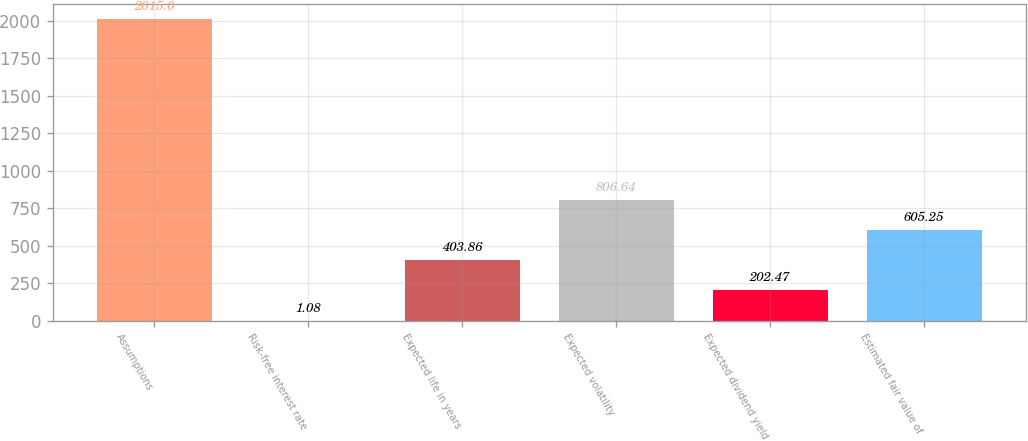<chart> <loc_0><loc_0><loc_500><loc_500><bar_chart><fcel>Assumptions<fcel>Risk-free interest rate<fcel>Expected life in years<fcel>Expected volatility<fcel>Expected dividend yield<fcel>Estimated fair value of<nl><fcel>2015<fcel>1.08<fcel>403.86<fcel>806.64<fcel>202.47<fcel>605.25<nl></chart> 